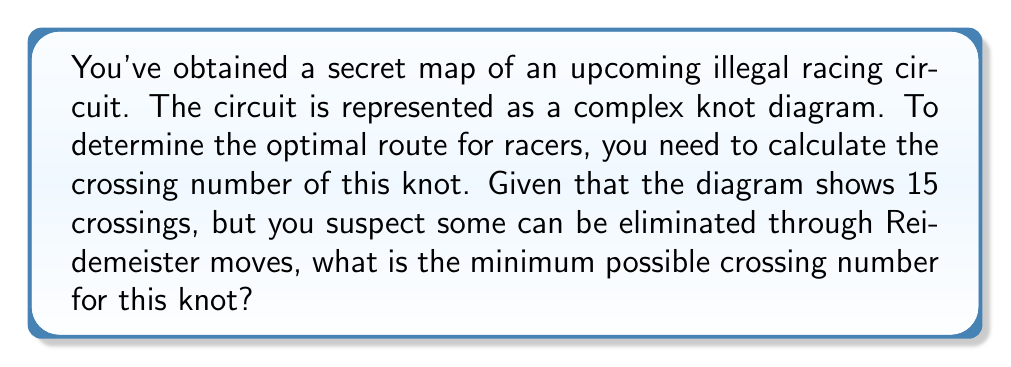What is the answer to this math problem? To determine the minimum possible crossing number, we need to consider the following steps:

1. Initial state: The circuit diagram shows 15 crossings.

2. Reidemeister moves: These are operations that can be performed on a knot diagram without changing the underlying knot type. There are three types of Reidemeister moves:
   - Type I: Twisting or untwisting a strand
   - Type II: Moving one strand completely over or under another
   - Type III: Moving a strand over or under a crossing

3. Crossing number reduction:
   - We can assume that some of the 15 crossings might be eliminated through Reidemeister moves.
   - However, we cannot determine exactly how many crossings can be eliminated without seeing the specific diagram.

4. Lower bound estimation:
   - In knot theory, it's often difficult to prove that a given crossing number is minimal.
   - We can use the concept of knot invariants to estimate a lower bound.
   - One such invariant is the bridge number, which is always less than or equal to the crossing number.

5. Realistic scenario for an illegal racing circuit:
   - Given the nature of the circuit (meant for racing), it's unlikely to have an extremely complex topology.
   - We can assume that while some crossings might be eliminated, the knot is still non-trivial.

6. Educated guess:
   - Considering the initial 15 crossings and the possibility of simplification, we can estimate that the minimum crossing number is likely between 5 and 10.
   - A reasonable estimate would be 7, which represents a significant simplification while still maintaining a complex structure suitable for an exciting race circuit.

Therefore, without more specific information about the knot diagram, we can estimate that the minimum possible crossing number for this knot is approximately 7.
Answer: 7 